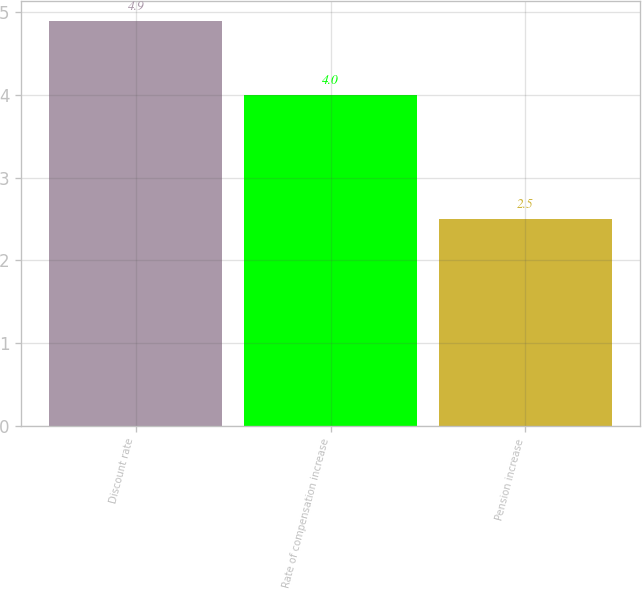Convert chart to OTSL. <chart><loc_0><loc_0><loc_500><loc_500><bar_chart><fcel>Discount rate<fcel>Rate of compensation increase<fcel>Pension increase<nl><fcel>4.9<fcel>4<fcel>2.5<nl></chart> 